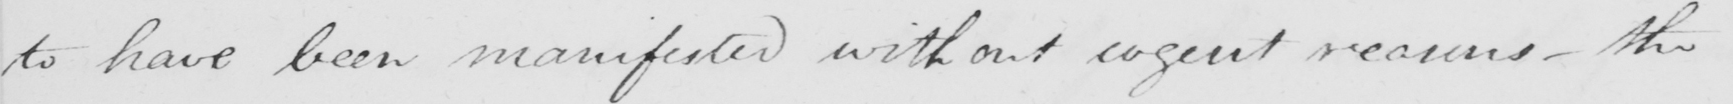What text is written in this handwritten line? to have been manifested without cogent reasons  _  the 